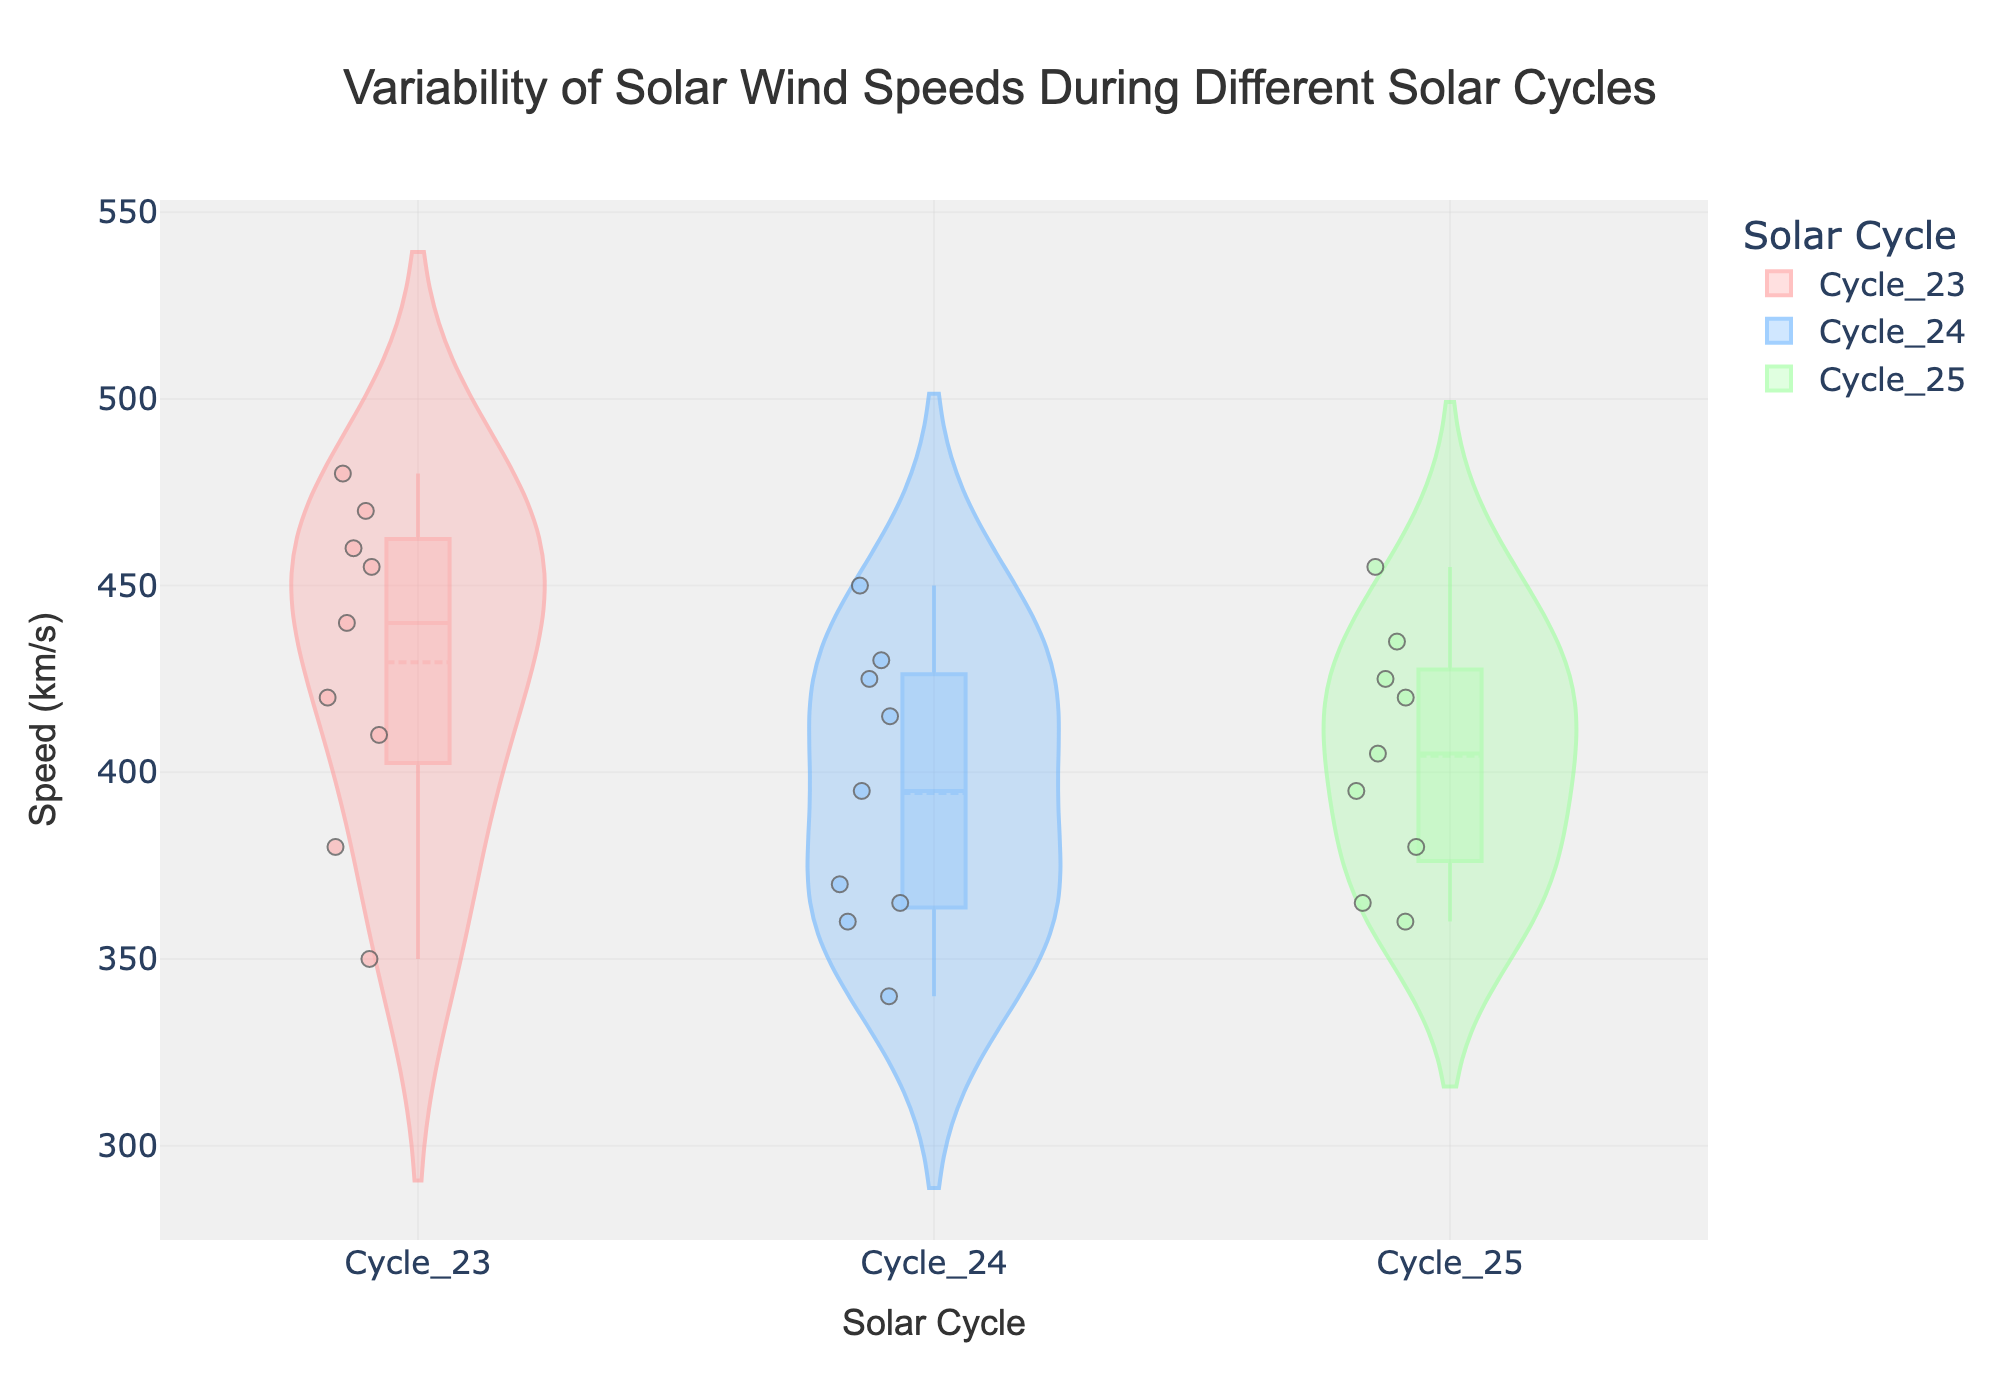What is the title of the figure? The title is located at the top center of the figure within the Plotly layout settings. It is formatted with a specific font and size, indicating the main topic of the plot.
Answer: Variability of Solar Wind Speeds During Different Solar Cycles What is the x-axis label? The x-axis label is positioned at the bottom of the figure in the layout settings. It describes the variable plotted horizontally on the figure, helping viewers understand the categories being compared.
Answer: Solar Cycle What is the y-axis label? The y-axis label is located on the left side of the figure as per the layout settings. It describes the variable plotted vertically in the figure, indicating what is being measured in the plot.
Answer: Speed (km/s) In which solar cycle do we observe the highest individual solar wind speed? By looking at the highest data points in each cycle's violin plot, we can identify the cycle with the maximum value. Cycle 23 has the highest individual point at approximately 480 km/s.
Answer: Cycle 23 What is the range of solar wind speeds in Solar Cycle 24? The range of solar wind speeds is the difference between the maximum and minimum values within Cycle 24, which can be seen by identifying the topmost and bottommost points within the violin plot for Cycle 24. The maximum is around 450 km/s and the minimum is around 340 km/s, so the range is 450 - 340.
Answer: 110 km/s Which solar cycle has the lowest median solar wind speed? The median is represented by the line inside the box plot within each violin. By observing these lines across cycles, Cycle 24 has the lowest median value compared to Cycles 23 and 25.
Answer: Cycle 24 How do the interquartile ranges (IQR) of solar wind speeds compare among the solar cycles? The IQR is represented by the height of the box in the box plot within each violin. By visually comparing these box heights, Cycle 23 seems to have the widest IQR, Cycle 25 is intermediate, and Cycle 24 has the narrowest IQR.
Answer: Cycle 23 > Cycle 25 > Cycle 24 Which solar cycle shows the least variability in solar wind speeds? Variability can be interpreted by the width of the violin plot and the spread of data points. The cycle with the least spread and the narrowest violin plot indicates the least variability. Cycle 24 appears to be the least variable given the narrower width and tighter spread of points.
Answer: Cycle 24 How do the mean values of solar wind speeds compare among the solar cycles? The mean value is indicated by a line across the violin plot. By observing and comparing these lines among the different cycles, Cycle 23 has a higher mean than Cycles 24 and 25, which have their lines positioned lower.
Answer: Cycle 23 > Cycle 25 ≈ Cycle 24 Which solar cycle has the most outliers? Outliers are points outside the whiskers of the box plot in the violin. By counting these points, Cycle 23 has the most outliers compared to Cycles 24 and 25.
Answer: Cycle 23 